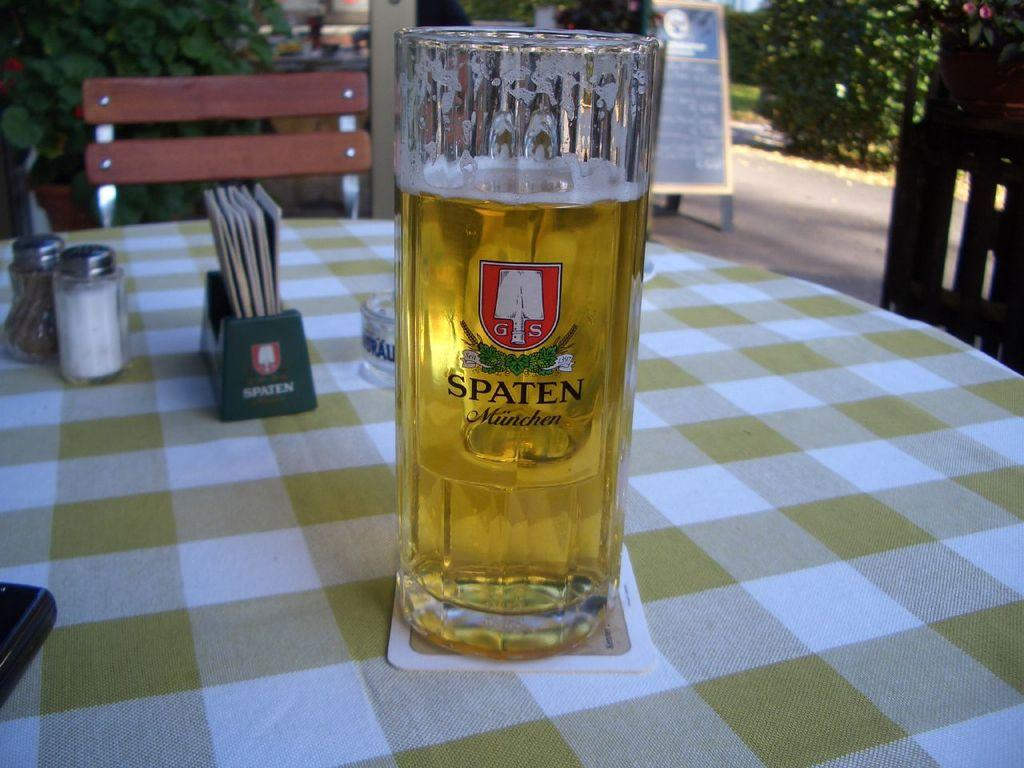<image>
Offer a succinct explanation of the picture presented. A glass of beer on which the word Spaten can be seen. 